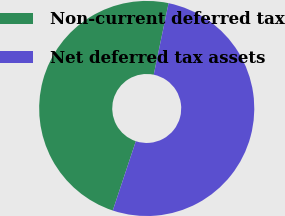<chart> <loc_0><loc_0><loc_500><loc_500><pie_chart><fcel>Non-current deferred tax<fcel>Net deferred tax assets<nl><fcel>48.15%<fcel>51.85%<nl></chart> 